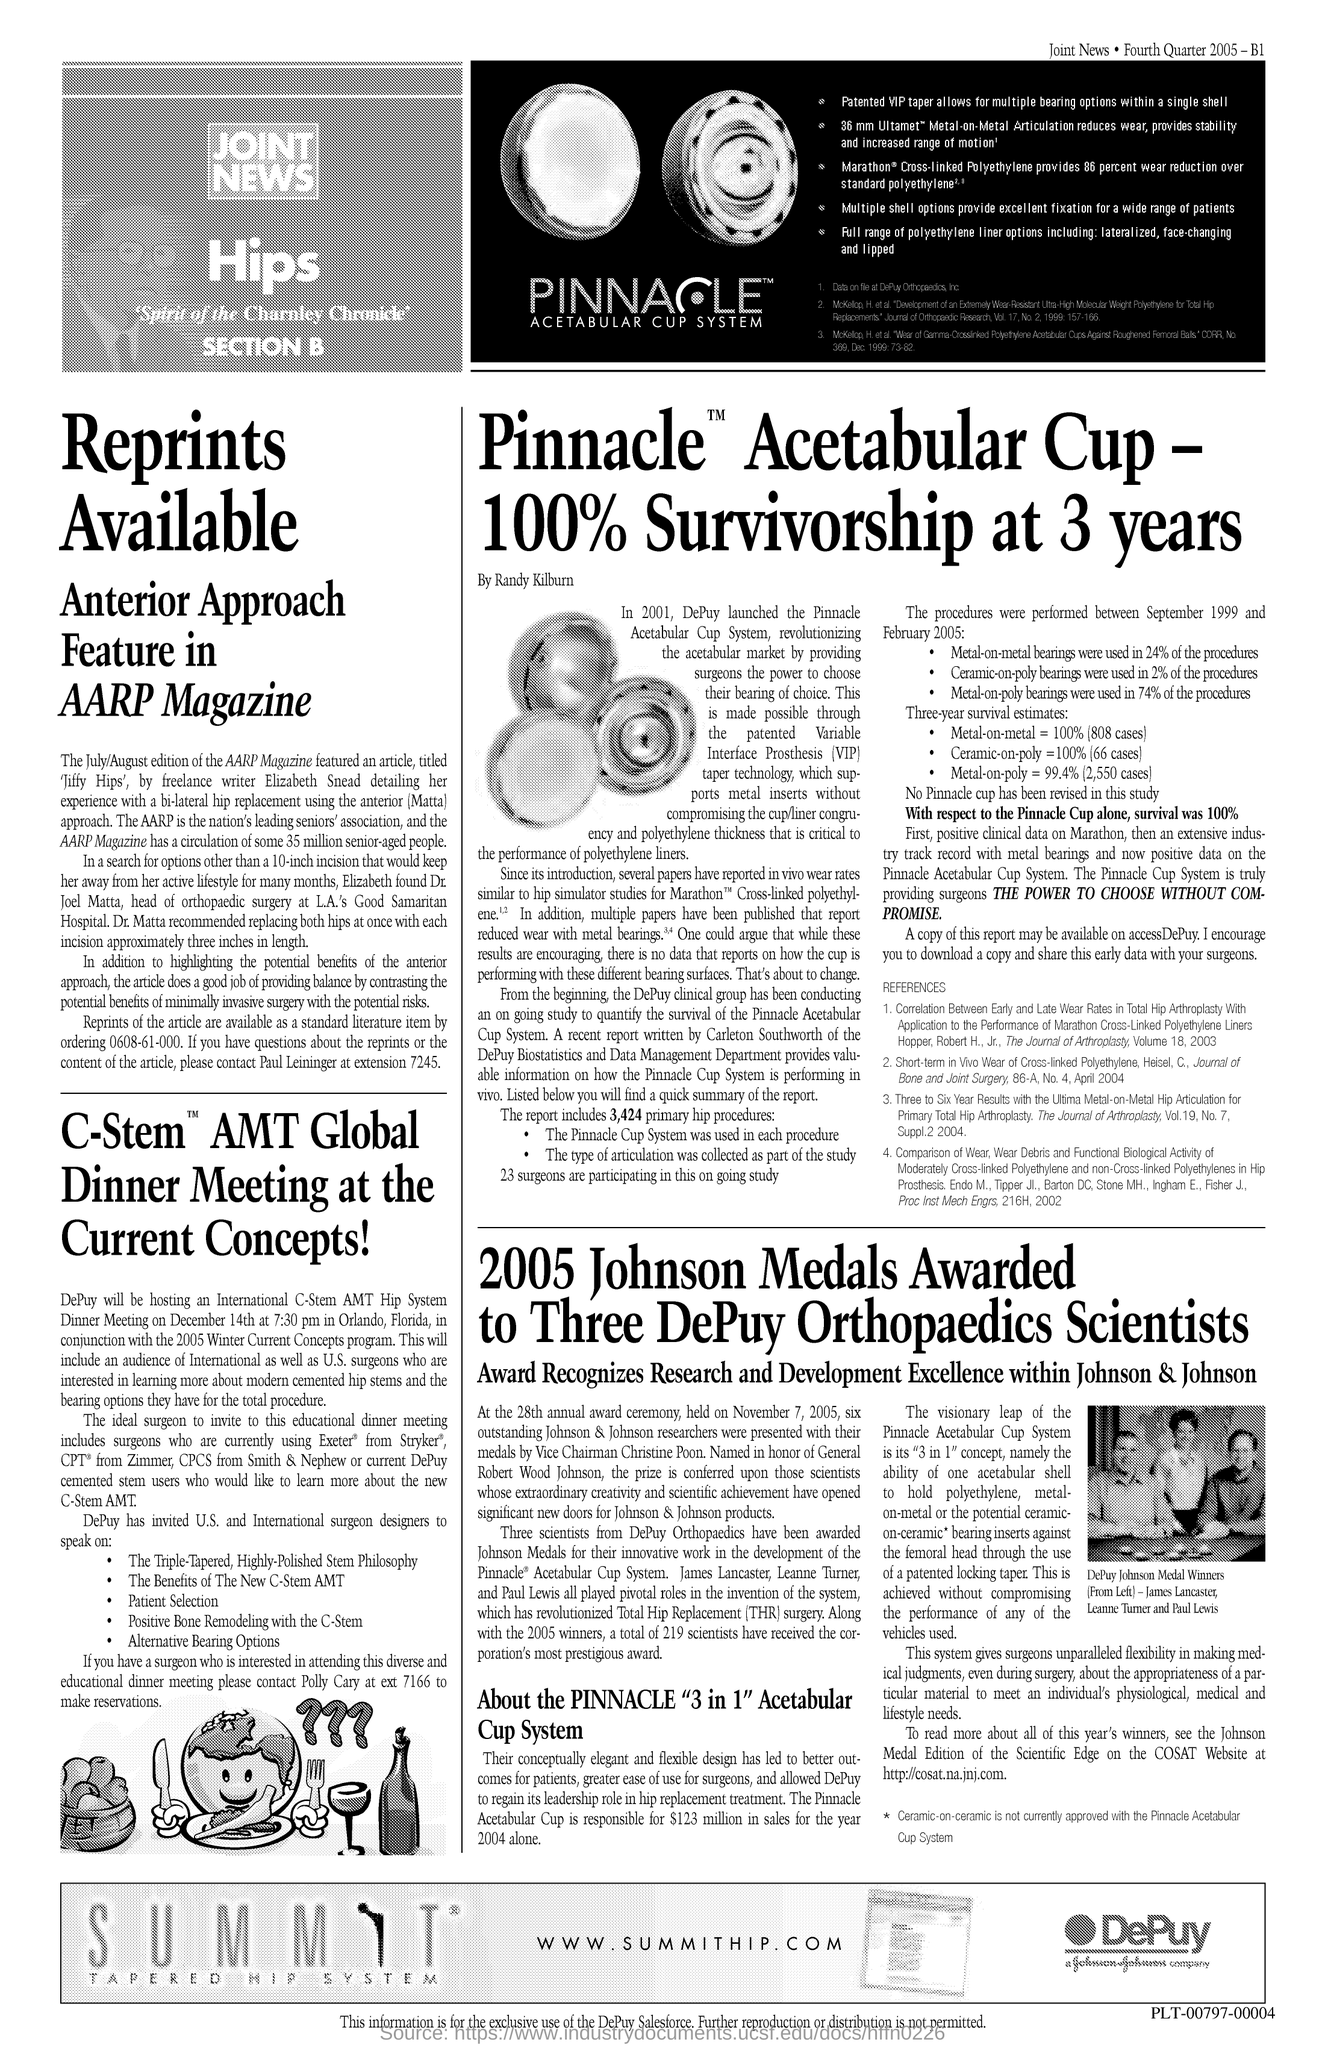What is the url mentioned in the document?
Offer a terse response. Www.summithip.com. 